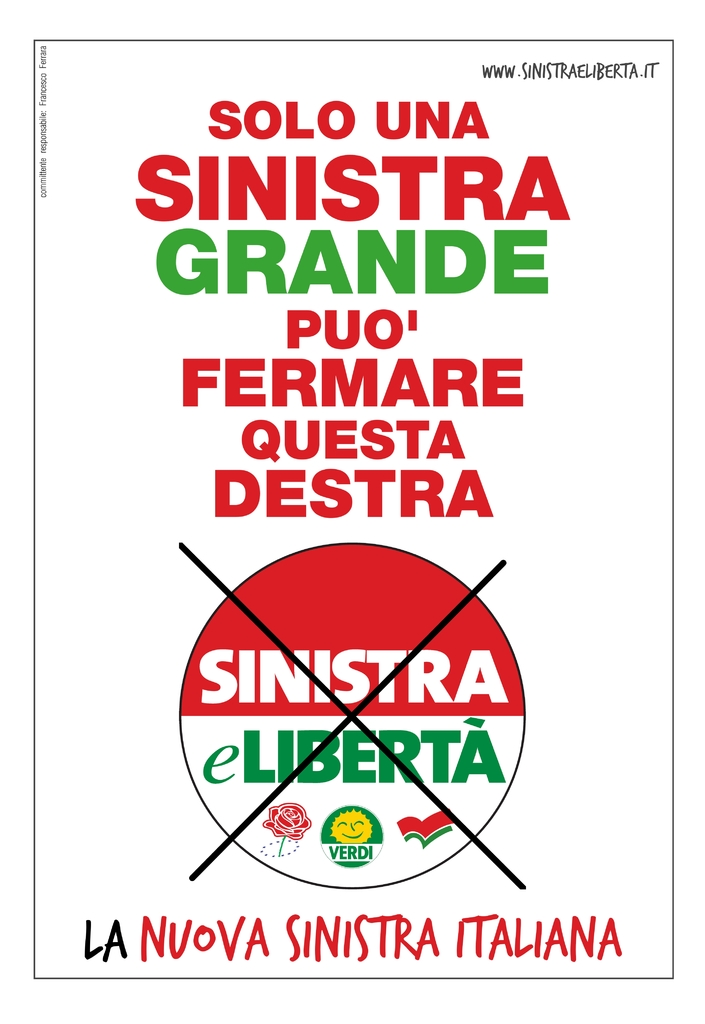Can you explain the significance of the crossed-out logo in the poster? The crossed-out logo of 'Sinistra eLiberta', which means 'Left and Freedom', along with the slogan, implies a criticism or displacement of the former ideologies or strategies of this group by advocating for a new, more effective leftist approach symbolized by 'La Nuova Sinistra Italiana' or 'The New Italian Left'. 